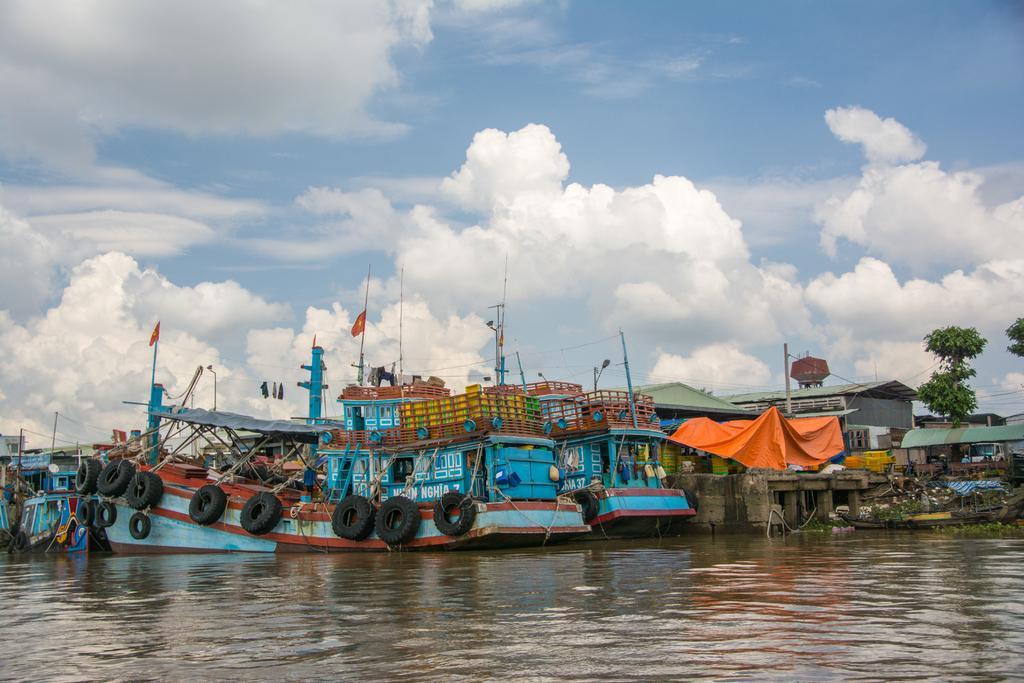How would you summarize this image in a sentence or two? In this image I can see in the middle there are blue color boats in the water, on the right side there are seeds and trees. At the top it is the cloudy sky, there are black color tubes to these boats. 